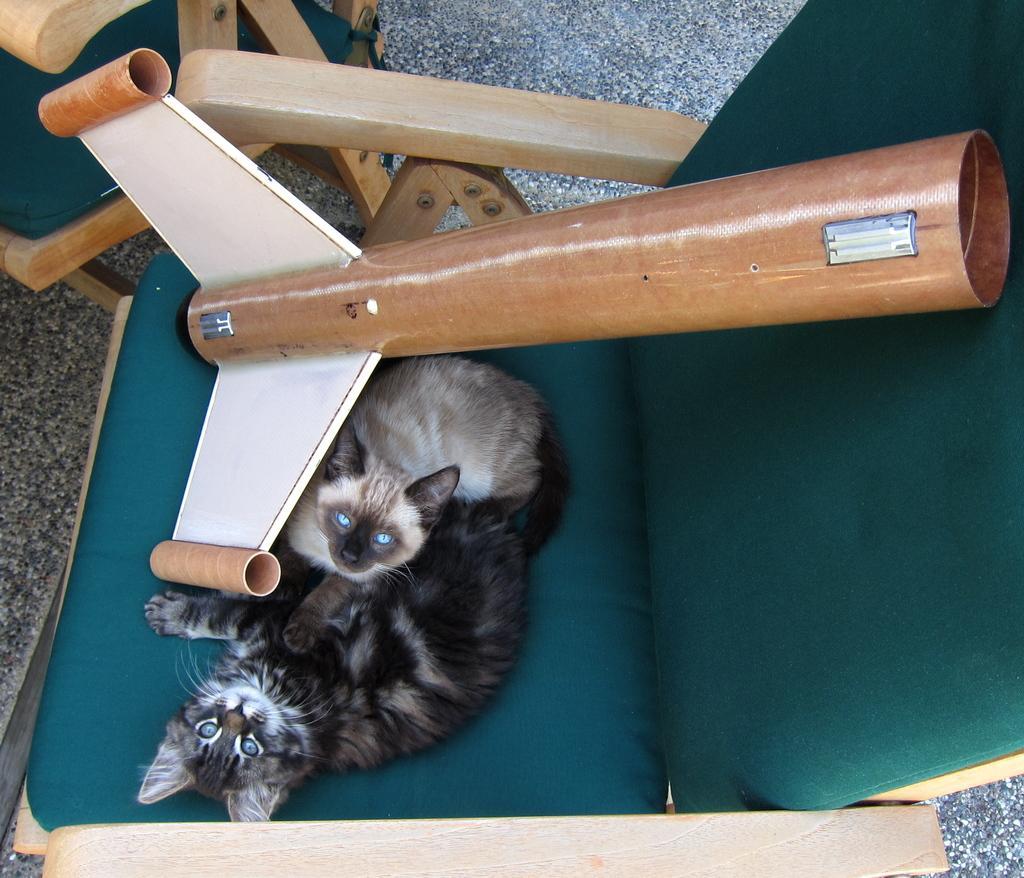How would you summarize this image in a sentence or two? In the picture we can see a chair on the floor, which is green in color on it, we can see two cats and a pole with two shafts in it and beside the chair we can see another chair on the floor. 